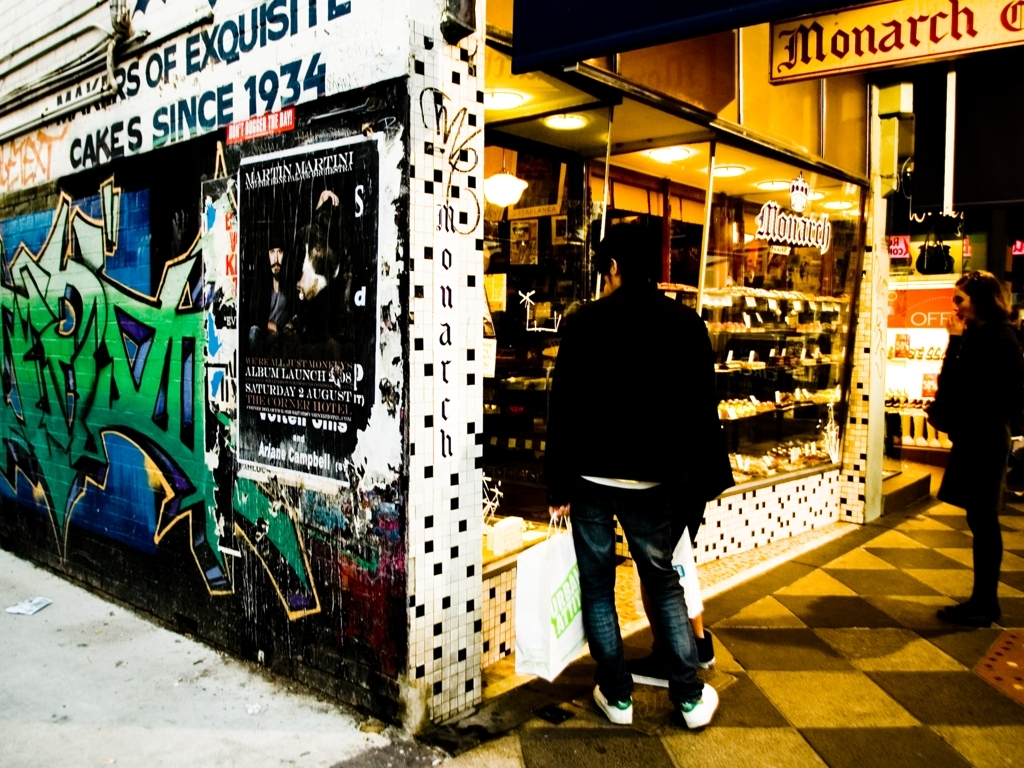What is the overall clarity of the image?
A. Excellent
B. Moderate
C. Low
D. High The overall clarity of the image is moderate, with certain aspects such as the graffiti and the storefront appearing clear while others, like distant objects and the darker regions, are less discernible. This balance yields a realistic depiction, not overly refined but with sufficient detail where it counts. 